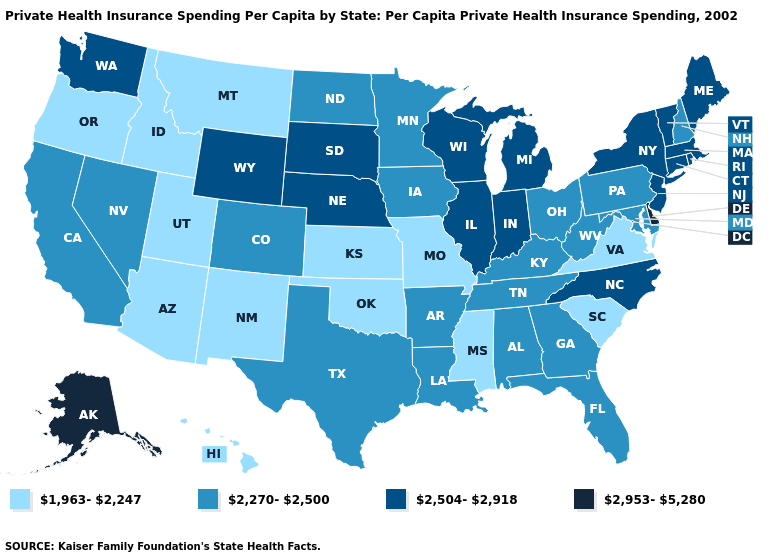Among the states that border Washington , which have the highest value?
Keep it brief. Idaho, Oregon. What is the lowest value in the Northeast?
Write a very short answer. 2,270-2,500. Name the states that have a value in the range 2,504-2,918?
Give a very brief answer. Connecticut, Illinois, Indiana, Maine, Massachusetts, Michigan, Nebraska, New Jersey, New York, North Carolina, Rhode Island, South Dakota, Vermont, Washington, Wisconsin, Wyoming. What is the value of South Dakota?
Concise answer only. 2,504-2,918. Name the states that have a value in the range 2,270-2,500?
Be succinct. Alabama, Arkansas, California, Colorado, Florida, Georgia, Iowa, Kentucky, Louisiana, Maryland, Minnesota, Nevada, New Hampshire, North Dakota, Ohio, Pennsylvania, Tennessee, Texas, West Virginia. Name the states that have a value in the range 1,963-2,247?
Concise answer only. Arizona, Hawaii, Idaho, Kansas, Mississippi, Missouri, Montana, New Mexico, Oklahoma, Oregon, South Carolina, Utah, Virginia. Name the states that have a value in the range 2,270-2,500?
Give a very brief answer. Alabama, Arkansas, California, Colorado, Florida, Georgia, Iowa, Kentucky, Louisiana, Maryland, Minnesota, Nevada, New Hampshire, North Dakota, Ohio, Pennsylvania, Tennessee, Texas, West Virginia. What is the value of Massachusetts?
Concise answer only. 2,504-2,918. What is the lowest value in the USA?
Be succinct. 1,963-2,247. Name the states that have a value in the range 2,270-2,500?
Write a very short answer. Alabama, Arkansas, California, Colorado, Florida, Georgia, Iowa, Kentucky, Louisiana, Maryland, Minnesota, Nevada, New Hampshire, North Dakota, Ohio, Pennsylvania, Tennessee, Texas, West Virginia. What is the value of Minnesota?
Be succinct. 2,270-2,500. Does Oklahoma have the lowest value in the South?
Keep it brief. Yes. Name the states that have a value in the range 1,963-2,247?
Write a very short answer. Arizona, Hawaii, Idaho, Kansas, Mississippi, Missouri, Montana, New Mexico, Oklahoma, Oregon, South Carolina, Utah, Virginia. What is the lowest value in the USA?
Quick response, please. 1,963-2,247. Name the states that have a value in the range 1,963-2,247?
Keep it brief. Arizona, Hawaii, Idaho, Kansas, Mississippi, Missouri, Montana, New Mexico, Oklahoma, Oregon, South Carolina, Utah, Virginia. 